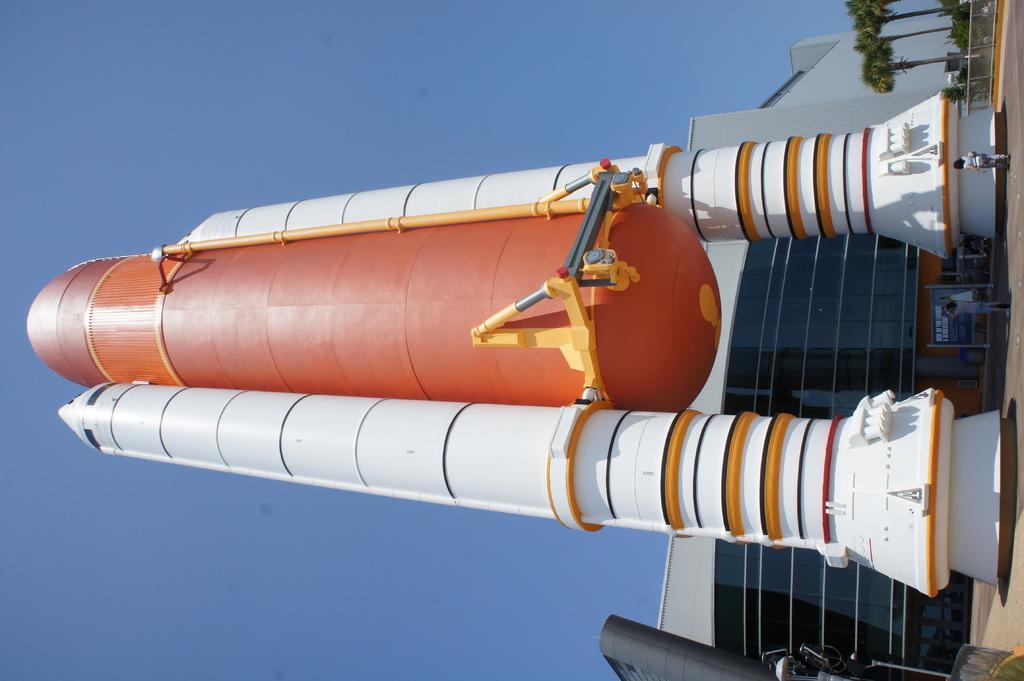In one or two sentences, can you explain what this image depicts? Here we can see an object in the shape of a rocket. In the background we can see a building, board, trees, two persons, and sky. 